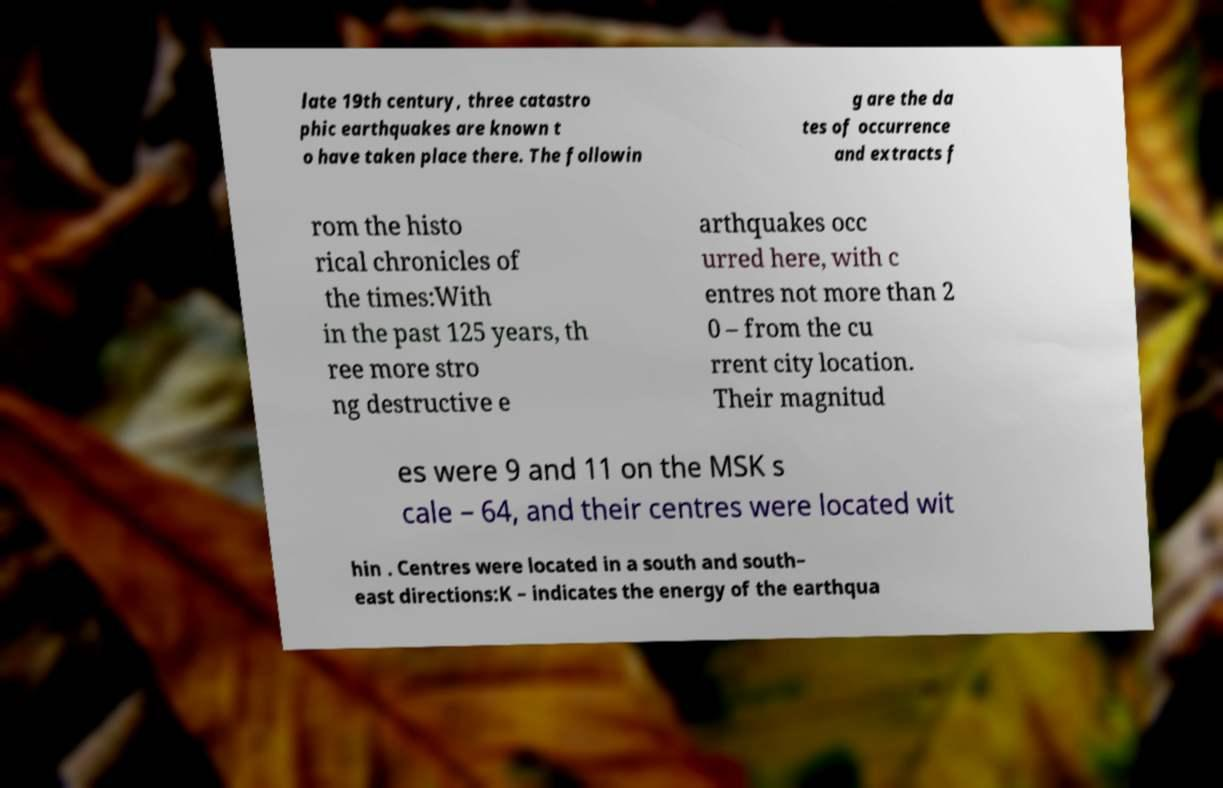Could you assist in decoding the text presented in this image and type it out clearly? late 19th century, three catastro phic earthquakes are known t o have taken place there. The followin g are the da tes of occurrence and extracts f rom the histo rical chronicles of the times:With in the past 125 years, th ree more stro ng destructive e arthquakes occ urred here, with c entres not more than 2 0 – from the cu rrent city location. Their magnitud es were 9 and 11 on the MSK s cale – 64, and their centres were located wit hin . Centres were located in a south and south– east directions:K – indicates the energy of the earthqua 